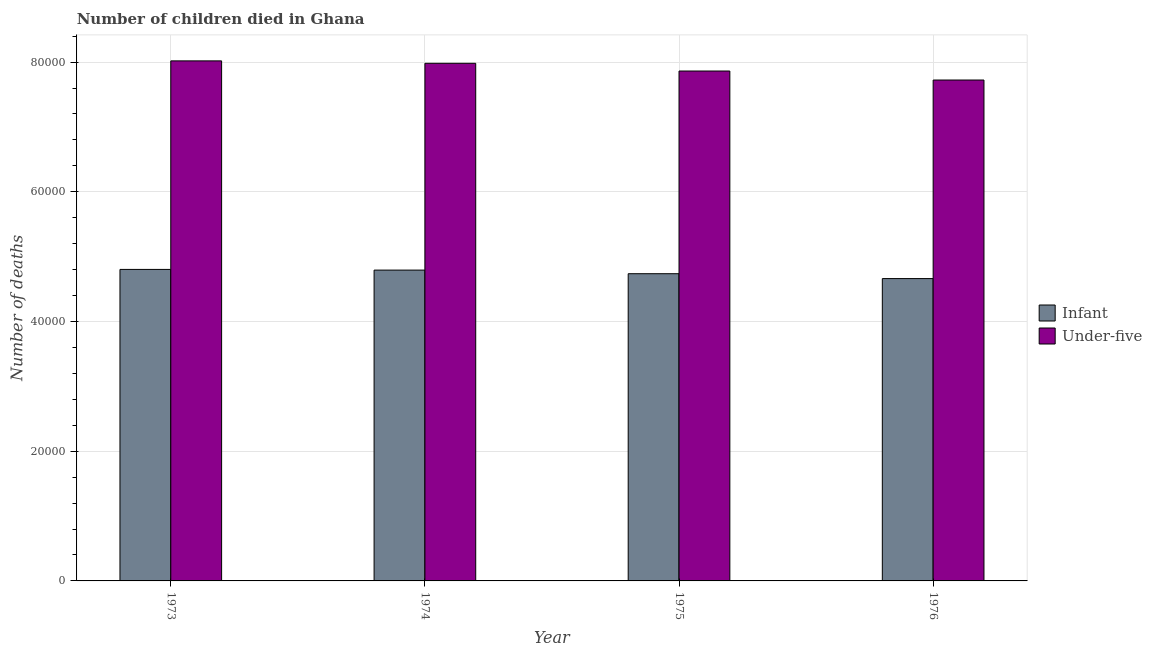How many different coloured bars are there?
Ensure brevity in your answer.  2. How many groups of bars are there?
Your answer should be very brief. 4. Are the number of bars per tick equal to the number of legend labels?
Keep it short and to the point. Yes. How many bars are there on the 4th tick from the left?
Ensure brevity in your answer.  2. How many bars are there on the 1st tick from the right?
Offer a very short reply. 2. What is the number of under-five deaths in 1976?
Ensure brevity in your answer.  7.72e+04. Across all years, what is the maximum number of under-five deaths?
Your response must be concise. 8.02e+04. Across all years, what is the minimum number of infant deaths?
Make the answer very short. 4.66e+04. In which year was the number of under-five deaths maximum?
Offer a terse response. 1973. In which year was the number of infant deaths minimum?
Your answer should be compact. 1976. What is the total number of under-five deaths in the graph?
Keep it short and to the point. 3.16e+05. What is the difference between the number of under-five deaths in 1973 and that in 1975?
Provide a short and direct response. 1564. What is the difference between the number of infant deaths in 1976 and the number of under-five deaths in 1975?
Provide a succinct answer. -750. What is the average number of under-five deaths per year?
Your answer should be compact. 7.90e+04. In how many years, is the number of under-five deaths greater than 76000?
Ensure brevity in your answer.  4. What is the ratio of the number of infant deaths in 1973 to that in 1974?
Make the answer very short. 1. Is the difference between the number of infant deaths in 1973 and 1975 greater than the difference between the number of under-five deaths in 1973 and 1975?
Give a very brief answer. No. What is the difference between the highest and the second highest number of under-five deaths?
Keep it short and to the point. 374. What is the difference between the highest and the lowest number of infant deaths?
Provide a succinct answer. 1413. In how many years, is the number of under-five deaths greater than the average number of under-five deaths taken over all years?
Make the answer very short. 2. What does the 2nd bar from the left in 1975 represents?
Give a very brief answer. Under-five. What does the 2nd bar from the right in 1973 represents?
Your answer should be compact. Infant. How many bars are there?
Give a very brief answer. 8. How many years are there in the graph?
Your response must be concise. 4. Are the values on the major ticks of Y-axis written in scientific E-notation?
Give a very brief answer. No. Does the graph contain any zero values?
Make the answer very short. No. Does the graph contain grids?
Your answer should be very brief. Yes. Where does the legend appear in the graph?
Give a very brief answer. Center right. How are the legend labels stacked?
Your answer should be compact. Vertical. What is the title of the graph?
Keep it short and to the point. Number of children died in Ghana. Does "Non-residents" appear as one of the legend labels in the graph?
Your answer should be compact. No. What is the label or title of the Y-axis?
Give a very brief answer. Number of deaths. What is the Number of deaths of Infant in 1973?
Make the answer very short. 4.80e+04. What is the Number of deaths of Under-five in 1973?
Keep it short and to the point. 8.02e+04. What is the Number of deaths of Infant in 1974?
Provide a succinct answer. 4.79e+04. What is the Number of deaths in Under-five in 1974?
Provide a succinct answer. 7.98e+04. What is the Number of deaths in Infant in 1975?
Ensure brevity in your answer.  4.74e+04. What is the Number of deaths in Under-five in 1975?
Keep it short and to the point. 7.86e+04. What is the Number of deaths in Infant in 1976?
Your answer should be compact. 4.66e+04. What is the Number of deaths in Under-five in 1976?
Your response must be concise. 7.72e+04. Across all years, what is the maximum Number of deaths in Infant?
Offer a very short reply. 4.80e+04. Across all years, what is the maximum Number of deaths of Under-five?
Offer a very short reply. 8.02e+04. Across all years, what is the minimum Number of deaths in Infant?
Your answer should be very brief. 4.66e+04. Across all years, what is the minimum Number of deaths of Under-five?
Your answer should be very brief. 7.72e+04. What is the total Number of deaths in Infant in the graph?
Your answer should be compact. 1.90e+05. What is the total Number of deaths in Under-five in the graph?
Keep it short and to the point. 3.16e+05. What is the difference between the Number of deaths in Infant in 1973 and that in 1974?
Give a very brief answer. 105. What is the difference between the Number of deaths in Under-five in 1973 and that in 1974?
Offer a very short reply. 374. What is the difference between the Number of deaths in Infant in 1973 and that in 1975?
Your answer should be compact. 663. What is the difference between the Number of deaths in Under-five in 1973 and that in 1975?
Make the answer very short. 1564. What is the difference between the Number of deaths of Infant in 1973 and that in 1976?
Provide a succinct answer. 1413. What is the difference between the Number of deaths of Under-five in 1973 and that in 1976?
Provide a succinct answer. 2952. What is the difference between the Number of deaths in Infant in 1974 and that in 1975?
Make the answer very short. 558. What is the difference between the Number of deaths in Under-five in 1974 and that in 1975?
Offer a terse response. 1190. What is the difference between the Number of deaths in Infant in 1974 and that in 1976?
Offer a very short reply. 1308. What is the difference between the Number of deaths in Under-five in 1974 and that in 1976?
Keep it short and to the point. 2578. What is the difference between the Number of deaths in Infant in 1975 and that in 1976?
Keep it short and to the point. 750. What is the difference between the Number of deaths of Under-five in 1975 and that in 1976?
Your answer should be very brief. 1388. What is the difference between the Number of deaths in Infant in 1973 and the Number of deaths in Under-five in 1974?
Your answer should be very brief. -3.18e+04. What is the difference between the Number of deaths of Infant in 1973 and the Number of deaths of Under-five in 1975?
Your answer should be compact. -3.06e+04. What is the difference between the Number of deaths in Infant in 1973 and the Number of deaths in Under-five in 1976?
Provide a succinct answer. -2.92e+04. What is the difference between the Number of deaths of Infant in 1974 and the Number of deaths of Under-five in 1975?
Keep it short and to the point. -3.07e+04. What is the difference between the Number of deaths in Infant in 1974 and the Number of deaths in Under-five in 1976?
Provide a short and direct response. -2.93e+04. What is the difference between the Number of deaths of Infant in 1975 and the Number of deaths of Under-five in 1976?
Your answer should be very brief. -2.99e+04. What is the average Number of deaths of Infant per year?
Offer a terse response. 4.75e+04. What is the average Number of deaths of Under-five per year?
Your answer should be compact. 7.90e+04. In the year 1973, what is the difference between the Number of deaths in Infant and Number of deaths in Under-five?
Ensure brevity in your answer.  -3.22e+04. In the year 1974, what is the difference between the Number of deaths of Infant and Number of deaths of Under-five?
Keep it short and to the point. -3.19e+04. In the year 1975, what is the difference between the Number of deaths in Infant and Number of deaths in Under-five?
Ensure brevity in your answer.  -3.13e+04. In the year 1976, what is the difference between the Number of deaths of Infant and Number of deaths of Under-five?
Provide a succinct answer. -3.06e+04. What is the ratio of the Number of deaths in Under-five in 1973 to that in 1975?
Your answer should be very brief. 1.02. What is the ratio of the Number of deaths in Infant in 1973 to that in 1976?
Make the answer very short. 1.03. What is the ratio of the Number of deaths in Under-five in 1973 to that in 1976?
Ensure brevity in your answer.  1.04. What is the ratio of the Number of deaths of Infant in 1974 to that in 1975?
Provide a succinct answer. 1.01. What is the ratio of the Number of deaths of Under-five in 1974 to that in 1975?
Make the answer very short. 1.02. What is the ratio of the Number of deaths in Infant in 1974 to that in 1976?
Your response must be concise. 1.03. What is the ratio of the Number of deaths in Under-five in 1974 to that in 1976?
Keep it short and to the point. 1.03. What is the ratio of the Number of deaths of Infant in 1975 to that in 1976?
Offer a terse response. 1.02. What is the difference between the highest and the second highest Number of deaths of Infant?
Offer a terse response. 105. What is the difference between the highest and the second highest Number of deaths of Under-five?
Provide a succinct answer. 374. What is the difference between the highest and the lowest Number of deaths in Infant?
Your response must be concise. 1413. What is the difference between the highest and the lowest Number of deaths in Under-five?
Your response must be concise. 2952. 